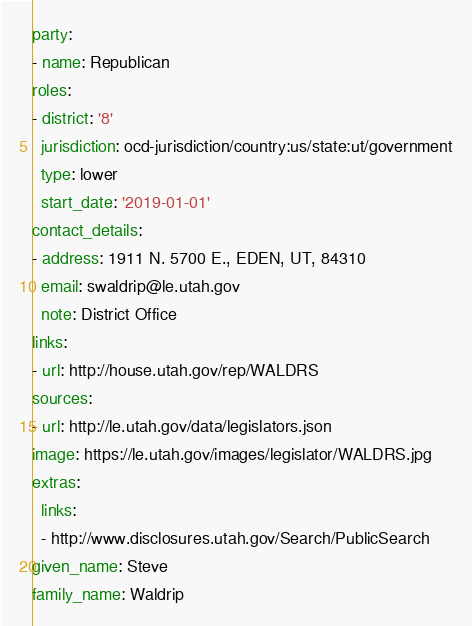<code> <loc_0><loc_0><loc_500><loc_500><_YAML_>party:
- name: Republican
roles:
- district: '8'
  jurisdiction: ocd-jurisdiction/country:us/state:ut/government
  type: lower
  start_date: '2019-01-01'
contact_details:
- address: 1911 N. 5700 E., EDEN, UT, 84310
  email: swaldrip@le.utah.gov
  note: District Office
links:
- url: http://house.utah.gov/rep/WALDRS
sources:
- url: http://le.utah.gov/data/legislators.json
image: https://le.utah.gov/images/legislator/WALDRS.jpg
extras:
  links:
  - http://www.disclosures.utah.gov/Search/PublicSearch
given_name: Steve
family_name: Waldrip
</code> 